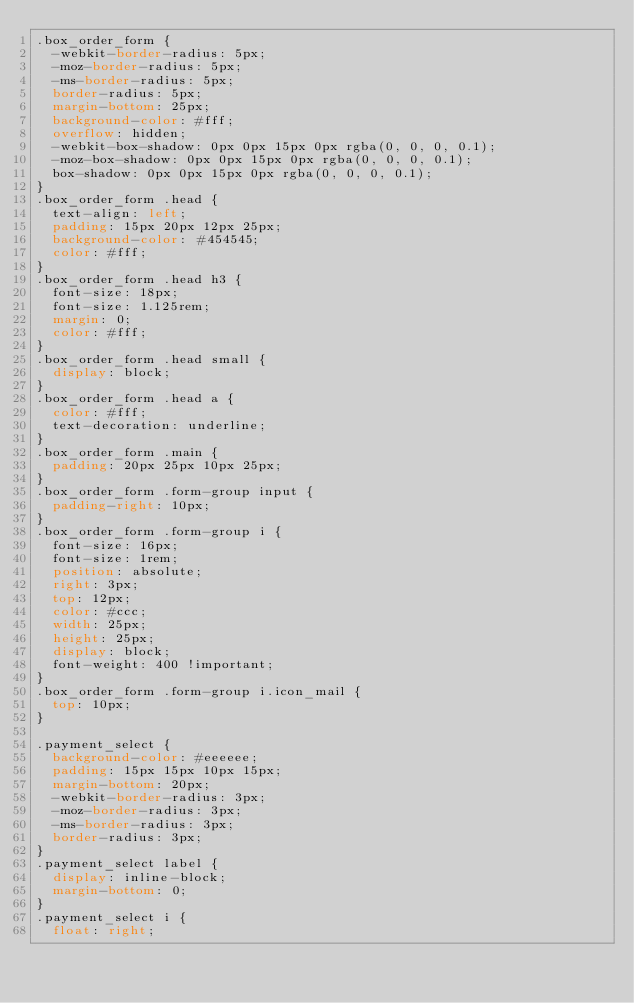Convert code to text. <code><loc_0><loc_0><loc_500><loc_500><_CSS_>.box_order_form {
  -webkit-border-radius: 5px;
  -moz-border-radius: 5px;
  -ms-border-radius: 5px;
  border-radius: 5px;
  margin-bottom: 25px;
  background-color: #fff;
  overflow: hidden;
  -webkit-box-shadow: 0px 0px 15px 0px rgba(0, 0, 0, 0.1);
  -moz-box-shadow: 0px 0px 15px 0px rgba(0, 0, 0, 0.1);
  box-shadow: 0px 0px 15px 0px rgba(0, 0, 0, 0.1);
}
.box_order_form .head {
  text-align: left;
  padding: 15px 20px 12px 25px;
  background-color: #454545;
  color: #fff;
}
.box_order_form .head h3 {
  font-size: 18px;
  font-size: 1.125rem;
  margin: 0;
  color: #fff;
}
.box_order_form .head small {
  display: block;
}
.box_order_form .head a {
  color: #fff;
  text-decoration: underline;
}
.box_order_form .main {
  padding: 20px 25px 10px 25px;
}
.box_order_form .form-group input {
  padding-right: 10px;
}
.box_order_form .form-group i {
  font-size: 16px;
  font-size: 1rem;
  position: absolute;
  right: 3px;
  top: 12px;
  color: #ccc;
  width: 25px;
  height: 25px;
  display: block;
  font-weight: 400 !important;
}
.box_order_form .form-group i.icon_mail {
  top: 10px;
}

.payment_select {
  background-color: #eeeeee;
  padding: 15px 15px 10px 15px;
  margin-bottom: 20px;
  -webkit-border-radius: 3px;
  -moz-border-radius: 3px;
  -ms-border-radius: 3px;
  border-radius: 3px;
}
.payment_select label {
  display: inline-block;
  margin-bottom: 0;
}
.payment_select i {
  float: right;</code> 